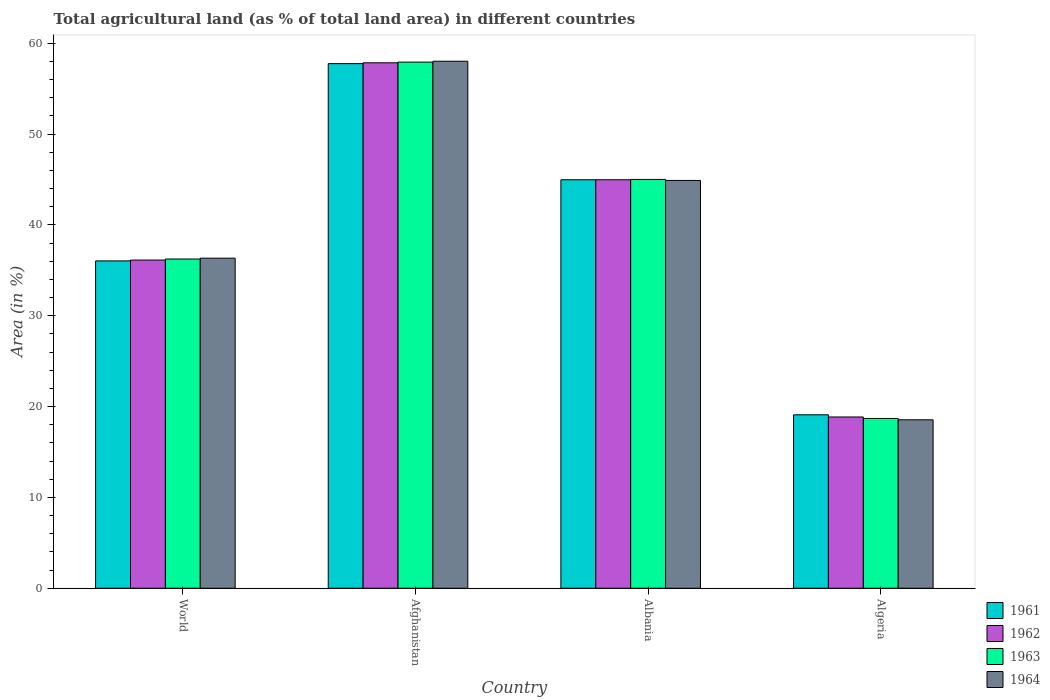How many different coloured bars are there?
Provide a succinct answer. 4. Are the number of bars per tick equal to the number of legend labels?
Ensure brevity in your answer.  Yes. Are the number of bars on each tick of the X-axis equal?
Your answer should be very brief. Yes. How many bars are there on the 1st tick from the left?
Offer a very short reply. 4. What is the label of the 3rd group of bars from the left?
Keep it short and to the point. Albania. In how many cases, is the number of bars for a given country not equal to the number of legend labels?
Provide a short and direct response. 0. What is the percentage of agricultural land in 1963 in Afghanistan?
Give a very brief answer. 57.91. Across all countries, what is the maximum percentage of agricultural land in 1963?
Your answer should be compact. 57.91. Across all countries, what is the minimum percentage of agricultural land in 1961?
Your answer should be compact. 19.09. In which country was the percentage of agricultural land in 1963 maximum?
Your response must be concise. Afghanistan. In which country was the percentage of agricultural land in 1961 minimum?
Ensure brevity in your answer.  Algeria. What is the total percentage of agricultural land in 1964 in the graph?
Provide a short and direct response. 157.78. What is the difference between the percentage of agricultural land in 1963 in Afghanistan and that in Algeria?
Your response must be concise. 39.23. What is the difference between the percentage of agricultural land in 1961 in Algeria and the percentage of agricultural land in 1964 in Albania?
Your response must be concise. -25.8. What is the average percentage of agricultural land in 1962 per country?
Make the answer very short. 39.44. What is the difference between the percentage of agricultural land of/in 1962 and percentage of agricultural land of/in 1961 in Afghanistan?
Offer a terse response. 0.09. What is the ratio of the percentage of agricultural land in 1963 in Afghanistan to that in Albania?
Offer a terse response. 1.29. Is the percentage of agricultural land in 1962 in Afghanistan less than that in Albania?
Make the answer very short. No. Is the difference between the percentage of agricultural land in 1962 in Algeria and World greater than the difference between the percentage of agricultural land in 1961 in Algeria and World?
Your answer should be very brief. No. What is the difference between the highest and the second highest percentage of agricultural land in 1963?
Your answer should be very brief. 21.67. What is the difference between the highest and the lowest percentage of agricultural land in 1963?
Your answer should be very brief. 39.23. Is it the case that in every country, the sum of the percentage of agricultural land in 1963 and percentage of agricultural land in 1961 is greater than the sum of percentage of agricultural land in 1962 and percentage of agricultural land in 1964?
Your response must be concise. No. What does the 3rd bar from the left in Albania represents?
Your answer should be very brief. 1963. Are all the bars in the graph horizontal?
Your answer should be very brief. No. How many countries are there in the graph?
Make the answer very short. 4. Does the graph contain grids?
Make the answer very short. No. How are the legend labels stacked?
Ensure brevity in your answer.  Vertical. What is the title of the graph?
Your answer should be very brief. Total agricultural land (as % of total land area) in different countries. What is the label or title of the X-axis?
Your response must be concise. Country. What is the label or title of the Y-axis?
Provide a short and direct response. Area (in %). What is the Area (in %) of 1961 in World?
Ensure brevity in your answer.  36.03. What is the Area (in %) in 1962 in World?
Offer a very short reply. 36.12. What is the Area (in %) of 1963 in World?
Provide a succinct answer. 36.24. What is the Area (in %) of 1964 in World?
Provide a short and direct response. 36.33. What is the Area (in %) of 1961 in Afghanistan?
Offer a terse response. 57.75. What is the Area (in %) in 1962 in Afghanistan?
Ensure brevity in your answer.  57.84. What is the Area (in %) of 1963 in Afghanistan?
Your answer should be compact. 57.91. What is the Area (in %) in 1964 in Afghanistan?
Offer a very short reply. 58.01. What is the Area (in %) of 1961 in Albania?
Give a very brief answer. 44.96. What is the Area (in %) of 1962 in Albania?
Give a very brief answer. 44.96. What is the Area (in %) of 1963 in Albania?
Provide a short and direct response. 45. What is the Area (in %) in 1964 in Albania?
Your response must be concise. 44.89. What is the Area (in %) of 1961 in Algeria?
Offer a very short reply. 19.09. What is the Area (in %) of 1962 in Algeria?
Give a very brief answer. 18.85. What is the Area (in %) of 1963 in Algeria?
Offer a very short reply. 18.69. What is the Area (in %) in 1964 in Algeria?
Offer a very short reply. 18.54. Across all countries, what is the maximum Area (in %) in 1961?
Keep it short and to the point. 57.75. Across all countries, what is the maximum Area (in %) in 1962?
Provide a short and direct response. 57.84. Across all countries, what is the maximum Area (in %) of 1963?
Provide a succinct answer. 57.91. Across all countries, what is the maximum Area (in %) of 1964?
Offer a very short reply. 58.01. Across all countries, what is the minimum Area (in %) of 1961?
Ensure brevity in your answer.  19.09. Across all countries, what is the minimum Area (in %) in 1962?
Your answer should be very brief. 18.85. Across all countries, what is the minimum Area (in %) in 1963?
Give a very brief answer. 18.69. Across all countries, what is the minimum Area (in %) in 1964?
Make the answer very short. 18.54. What is the total Area (in %) in 1961 in the graph?
Ensure brevity in your answer.  157.83. What is the total Area (in %) of 1962 in the graph?
Your answer should be compact. 157.78. What is the total Area (in %) of 1963 in the graph?
Make the answer very short. 157.84. What is the total Area (in %) in 1964 in the graph?
Make the answer very short. 157.78. What is the difference between the Area (in %) in 1961 in World and that in Afghanistan?
Your answer should be very brief. -21.71. What is the difference between the Area (in %) in 1962 in World and that in Afghanistan?
Keep it short and to the point. -21.71. What is the difference between the Area (in %) in 1963 in World and that in Afghanistan?
Provide a succinct answer. -21.67. What is the difference between the Area (in %) of 1964 in World and that in Afghanistan?
Your response must be concise. -21.68. What is the difference between the Area (in %) of 1961 in World and that in Albania?
Your answer should be compact. -8.93. What is the difference between the Area (in %) of 1962 in World and that in Albania?
Ensure brevity in your answer.  -8.84. What is the difference between the Area (in %) of 1963 in World and that in Albania?
Your answer should be very brief. -8.76. What is the difference between the Area (in %) of 1964 in World and that in Albania?
Your answer should be very brief. -8.56. What is the difference between the Area (in %) in 1961 in World and that in Algeria?
Your response must be concise. 16.94. What is the difference between the Area (in %) of 1962 in World and that in Algeria?
Provide a short and direct response. 17.27. What is the difference between the Area (in %) in 1963 in World and that in Algeria?
Provide a short and direct response. 17.55. What is the difference between the Area (in %) in 1964 in World and that in Algeria?
Give a very brief answer. 17.79. What is the difference between the Area (in %) in 1961 in Afghanistan and that in Albania?
Provide a succinct answer. 12.78. What is the difference between the Area (in %) of 1962 in Afghanistan and that in Albania?
Make the answer very short. 12.87. What is the difference between the Area (in %) in 1963 in Afghanistan and that in Albania?
Give a very brief answer. 12.91. What is the difference between the Area (in %) of 1964 in Afghanistan and that in Albania?
Keep it short and to the point. 13.12. What is the difference between the Area (in %) in 1961 in Afghanistan and that in Algeria?
Provide a succinct answer. 38.65. What is the difference between the Area (in %) in 1962 in Afghanistan and that in Algeria?
Your response must be concise. 38.99. What is the difference between the Area (in %) of 1963 in Afghanistan and that in Algeria?
Give a very brief answer. 39.23. What is the difference between the Area (in %) of 1964 in Afghanistan and that in Algeria?
Provide a succinct answer. 39.47. What is the difference between the Area (in %) of 1961 in Albania and that in Algeria?
Your answer should be compact. 25.87. What is the difference between the Area (in %) of 1962 in Albania and that in Algeria?
Ensure brevity in your answer.  26.11. What is the difference between the Area (in %) of 1963 in Albania and that in Algeria?
Give a very brief answer. 26.31. What is the difference between the Area (in %) of 1964 in Albania and that in Algeria?
Your answer should be compact. 26.35. What is the difference between the Area (in %) of 1961 in World and the Area (in %) of 1962 in Afghanistan?
Provide a succinct answer. -21.8. What is the difference between the Area (in %) of 1961 in World and the Area (in %) of 1963 in Afghanistan?
Provide a short and direct response. -21.88. What is the difference between the Area (in %) in 1961 in World and the Area (in %) in 1964 in Afghanistan?
Provide a succinct answer. -21.98. What is the difference between the Area (in %) of 1962 in World and the Area (in %) of 1963 in Afghanistan?
Give a very brief answer. -21.79. What is the difference between the Area (in %) of 1962 in World and the Area (in %) of 1964 in Afghanistan?
Make the answer very short. -21.89. What is the difference between the Area (in %) in 1963 in World and the Area (in %) in 1964 in Afghanistan?
Keep it short and to the point. -21.77. What is the difference between the Area (in %) of 1961 in World and the Area (in %) of 1962 in Albania?
Give a very brief answer. -8.93. What is the difference between the Area (in %) of 1961 in World and the Area (in %) of 1963 in Albania?
Give a very brief answer. -8.97. What is the difference between the Area (in %) in 1961 in World and the Area (in %) in 1964 in Albania?
Offer a terse response. -8.86. What is the difference between the Area (in %) of 1962 in World and the Area (in %) of 1963 in Albania?
Ensure brevity in your answer.  -8.88. What is the difference between the Area (in %) of 1962 in World and the Area (in %) of 1964 in Albania?
Provide a succinct answer. -8.77. What is the difference between the Area (in %) in 1963 in World and the Area (in %) in 1964 in Albania?
Your answer should be very brief. -8.65. What is the difference between the Area (in %) of 1961 in World and the Area (in %) of 1962 in Algeria?
Provide a succinct answer. 17.18. What is the difference between the Area (in %) in 1961 in World and the Area (in %) in 1963 in Algeria?
Keep it short and to the point. 17.34. What is the difference between the Area (in %) of 1961 in World and the Area (in %) of 1964 in Algeria?
Keep it short and to the point. 17.49. What is the difference between the Area (in %) in 1962 in World and the Area (in %) in 1963 in Algeria?
Make the answer very short. 17.44. What is the difference between the Area (in %) of 1962 in World and the Area (in %) of 1964 in Algeria?
Offer a terse response. 17.58. What is the difference between the Area (in %) of 1963 in World and the Area (in %) of 1964 in Algeria?
Your response must be concise. 17.7. What is the difference between the Area (in %) in 1961 in Afghanistan and the Area (in %) in 1962 in Albania?
Offer a terse response. 12.78. What is the difference between the Area (in %) in 1961 in Afghanistan and the Area (in %) in 1963 in Albania?
Your answer should be very brief. 12.75. What is the difference between the Area (in %) in 1961 in Afghanistan and the Area (in %) in 1964 in Albania?
Ensure brevity in your answer.  12.86. What is the difference between the Area (in %) of 1962 in Afghanistan and the Area (in %) of 1963 in Albania?
Your response must be concise. 12.84. What is the difference between the Area (in %) of 1962 in Afghanistan and the Area (in %) of 1964 in Albania?
Offer a terse response. 12.95. What is the difference between the Area (in %) of 1963 in Afghanistan and the Area (in %) of 1964 in Albania?
Offer a very short reply. 13.02. What is the difference between the Area (in %) of 1961 in Afghanistan and the Area (in %) of 1962 in Algeria?
Offer a very short reply. 38.89. What is the difference between the Area (in %) of 1961 in Afghanistan and the Area (in %) of 1963 in Algeria?
Your answer should be very brief. 39.06. What is the difference between the Area (in %) of 1961 in Afghanistan and the Area (in %) of 1964 in Algeria?
Provide a succinct answer. 39.2. What is the difference between the Area (in %) of 1962 in Afghanistan and the Area (in %) of 1963 in Algeria?
Your response must be concise. 39.15. What is the difference between the Area (in %) in 1962 in Afghanistan and the Area (in %) in 1964 in Algeria?
Offer a very short reply. 39.3. What is the difference between the Area (in %) of 1963 in Afghanistan and the Area (in %) of 1964 in Algeria?
Your answer should be very brief. 39.37. What is the difference between the Area (in %) of 1961 in Albania and the Area (in %) of 1962 in Algeria?
Offer a very short reply. 26.11. What is the difference between the Area (in %) in 1961 in Albania and the Area (in %) in 1963 in Algeria?
Ensure brevity in your answer.  26.28. What is the difference between the Area (in %) in 1961 in Albania and the Area (in %) in 1964 in Algeria?
Make the answer very short. 26.42. What is the difference between the Area (in %) in 1962 in Albania and the Area (in %) in 1963 in Algeria?
Give a very brief answer. 26.28. What is the difference between the Area (in %) in 1962 in Albania and the Area (in %) in 1964 in Algeria?
Keep it short and to the point. 26.42. What is the difference between the Area (in %) in 1963 in Albania and the Area (in %) in 1964 in Algeria?
Provide a short and direct response. 26.46. What is the average Area (in %) in 1961 per country?
Your answer should be very brief. 39.46. What is the average Area (in %) of 1962 per country?
Your response must be concise. 39.44. What is the average Area (in %) of 1963 per country?
Offer a terse response. 39.46. What is the average Area (in %) in 1964 per country?
Ensure brevity in your answer.  39.44. What is the difference between the Area (in %) of 1961 and Area (in %) of 1962 in World?
Your answer should be compact. -0.09. What is the difference between the Area (in %) of 1961 and Area (in %) of 1963 in World?
Offer a very short reply. -0.21. What is the difference between the Area (in %) of 1961 and Area (in %) of 1964 in World?
Make the answer very short. -0.3. What is the difference between the Area (in %) in 1962 and Area (in %) in 1963 in World?
Your answer should be very brief. -0.12. What is the difference between the Area (in %) in 1962 and Area (in %) in 1964 in World?
Your response must be concise. -0.21. What is the difference between the Area (in %) in 1963 and Area (in %) in 1964 in World?
Offer a very short reply. -0.09. What is the difference between the Area (in %) of 1961 and Area (in %) of 1962 in Afghanistan?
Provide a succinct answer. -0.09. What is the difference between the Area (in %) of 1961 and Area (in %) of 1963 in Afghanistan?
Your response must be concise. -0.17. What is the difference between the Area (in %) in 1961 and Area (in %) in 1964 in Afghanistan?
Offer a terse response. -0.27. What is the difference between the Area (in %) in 1962 and Area (in %) in 1963 in Afghanistan?
Your answer should be very brief. -0.08. What is the difference between the Area (in %) of 1962 and Area (in %) of 1964 in Afghanistan?
Your answer should be very brief. -0.17. What is the difference between the Area (in %) of 1963 and Area (in %) of 1964 in Afghanistan?
Make the answer very short. -0.1. What is the difference between the Area (in %) in 1961 and Area (in %) in 1962 in Albania?
Offer a terse response. 0. What is the difference between the Area (in %) in 1961 and Area (in %) in 1963 in Albania?
Provide a short and direct response. -0.04. What is the difference between the Area (in %) of 1961 and Area (in %) of 1964 in Albania?
Give a very brief answer. 0.07. What is the difference between the Area (in %) in 1962 and Area (in %) in 1963 in Albania?
Your answer should be very brief. -0.04. What is the difference between the Area (in %) of 1962 and Area (in %) of 1964 in Albania?
Offer a very short reply. 0.07. What is the difference between the Area (in %) of 1963 and Area (in %) of 1964 in Albania?
Provide a succinct answer. 0.11. What is the difference between the Area (in %) in 1961 and Area (in %) in 1962 in Algeria?
Provide a succinct answer. 0.24. What is the difference between the Area (in %) of 1961 and Area (in %) of 1963 in Algeria?
Make the answer very short. 0.4. What is the difference between the Area (in %) of 1961 and Area (in %) of 1964 in Algeria?
Offer a very short reply. 0.55. What is the difference between the Area (in %) of 1962 and Area (in %) of 1963 in Algeria?
Give a very brief answer. 0.16. What is the difference between the Area (in %) of 1962 and Area (in %) of 1964 in Algeria?
Your answer should be compact. 0.31. What is the difference between the Area (in %) in 1963 and Area (in %) in 1964 in Algeria?
Provide a short and direct response. 0.15. What is the ratio of the Area (in %) in 1961 in World to that in Afghanistan?
Your answer should be very brief. 0.62. What is the ratio of the Area (in %) of 1962 in World to that in Afghanistan?
Offer a very short reply. 0.62. What is the ratio of the Area (in %) in 1963 in World to that in Afghanistan?
Ensure brevity in your answer.  0.63. What is the ratio of the Area (in %) in 1964 in World to that in Afghanistan?
Offer a very short reply. 0.63. What is the ratio of the Area (in %) in 1961 in World to that in Albania?
Keep it short and to the point. 0.8. What is the ratio of the Area (in %) of 1962 in World to that in Albania?
Offer a terse response. 0.8. What is the ratio of the Area (in %) in 1963 in World to that in Albania?
Provide a short and direct response. 0.81. What is the ratio of the Area (in %) of 1964 in World to that in Albania?
Provide a succinct answer. 0.81. What is the ratio of the Area (in %) in 1961 in World to that in Algeria?
Your answer should be compact. 1.89. What is the ratio of the Area (in %) of 1962 in World to that in Algeria?
Provide a short and direct response. 1.92. What is the ratio of the Area (in %) of 1963 in World to that in Algeria?
Offer a very short reply. 1.94. What is the ratio of the Area (in %) in 1964 in World to that in Algeria?
Provide a succinct answer. 1.96. What is the ratio of the Area (in %) in 1961 in Afghanistan to that in Albania?
Your answer should be very brief. 1.28. What is the ratio of the Area (in %) of 1962 in Afghanistan to that in Albania?
Your answer should be very brief. 1.29. What is the ratio of the Area (in %) in 1963 in Afghanistan to that in Albania?
Make the answer very short. 1.29. What is the ratio of the Area (in %) of 1964 in Afghanistan to that in Albania?
Offer a terse response. 1.29. What is the ratio of the Area (in %) of 1961 in Afghanistan to that in Algeria?
Make the answer very short. 3.02. What is the ratio of the Area (in %) of 1962 in Afghanistan to that in Algeria?
Give a very brief answer. 3.07. What is the ratio of the Area (in %) in 1963 in Afghanistan to that in Algeria?
Your answer should be very brief. 3.1. What is the ratio of the Area (in %) in 1964 in Afghanistan to that in Algeria?
Make the answer very short. 3.13. What is the ratio of the Area (in %) in 1961 in Albania to that in Algeria?
Ensure brevity in your answer.  2.36. What is the ratio of the Area (in %) of 1962 in Albania to that in Algeria?
Your response must be concise. 2.39. What is the ratio of the Area (in %) in 1963 in Albania to that in Algeria?
Offer a terse response. 2.41. What is the ratio of the Area (in %) in 1964 in Albania to that in Algeria?
Offer a terse response. 2.42. What is the difference between the highest and the second highest Area (in %) of 1961?
Your answer should be very brief. 12.78. What is the difference between the highest and the second highest Area (in %) in 1962?
Offer a very short reply. 12.87. What is the difference between the highest and the second highest Area (in %) of 1963?
Make the answer very short. 12.91. What is the difference between the highest and the second highest Area (in %) of 1964?
Your response must be concise. 13.12. What is the difference between the highest and the lowest Area (in %) of 1961?
Keep it short and to the point. 38.65. What is the difference between the highest and the lowest Area (in %) in 1962?
Offer a terse response. 38.99. What is the difference between the highest and the lowest Area (in %) of 1963?
Make the answer very short. 39.23. What is the difference between the highest and the lowest Area (in %) of 1964?
Ensure brevity in your answer.  39.47. 